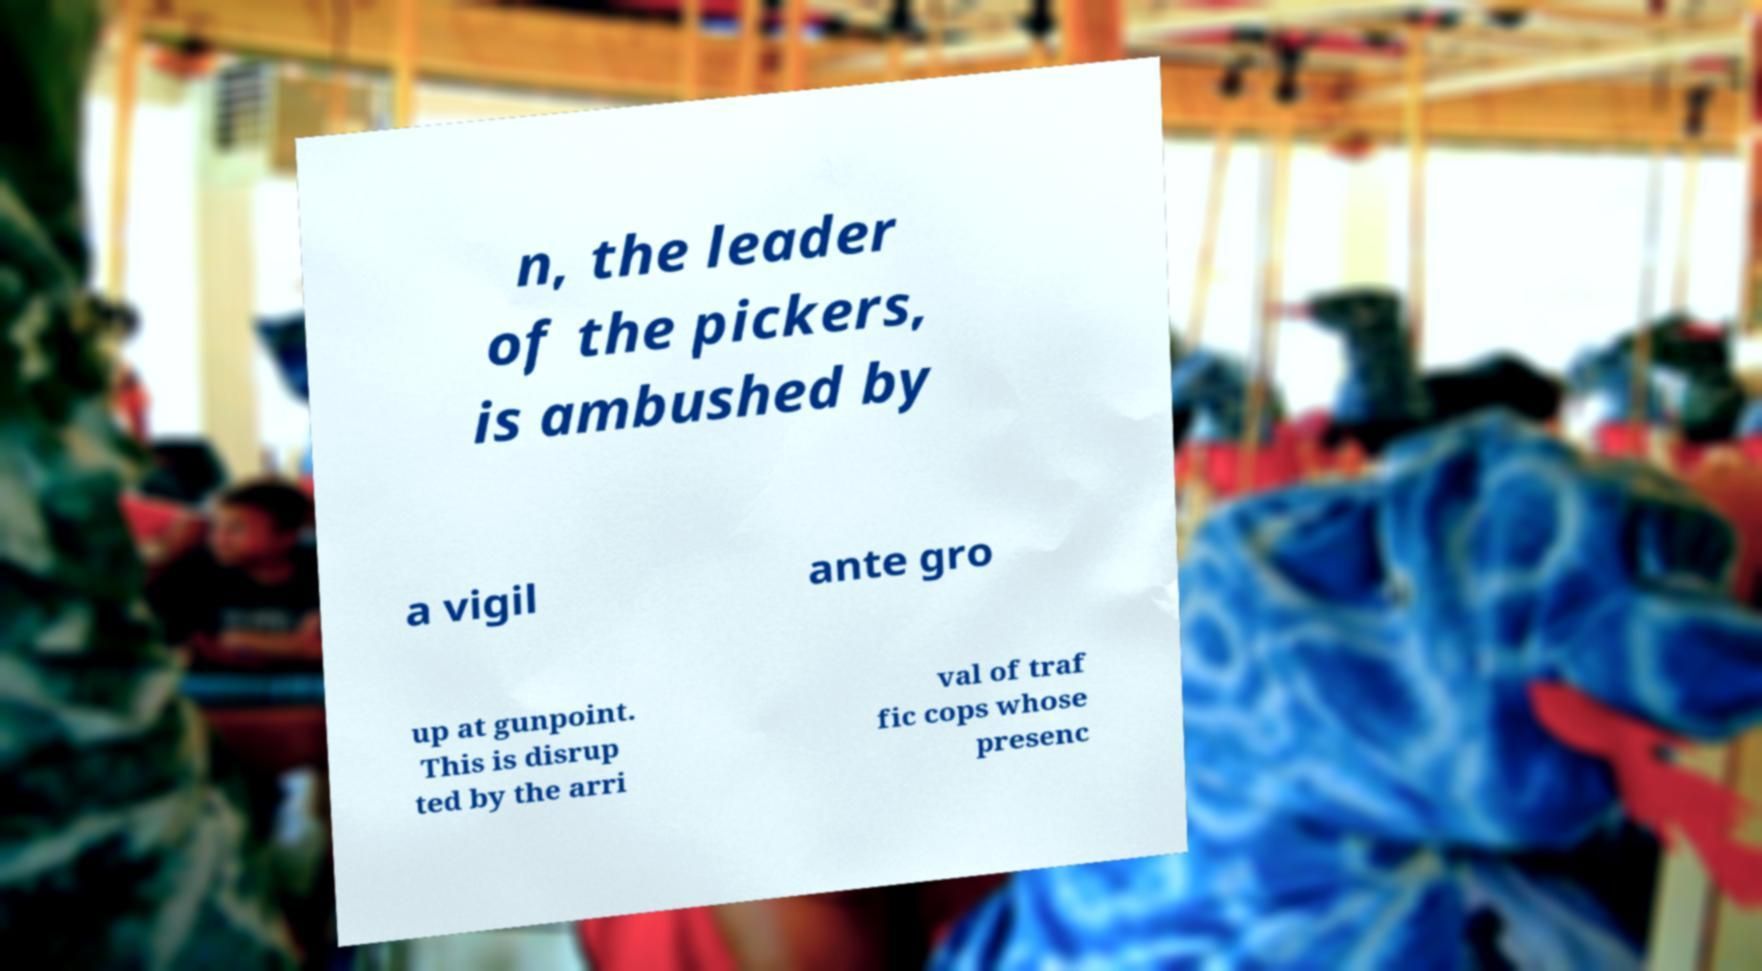Can you accurately transcribe the text from the provided image for me? n, the leader of the pickers, is ambushed by a vigil ante gro up at gunpoint. This is disrup ted by the arri val of traf fic cops whose presenc 